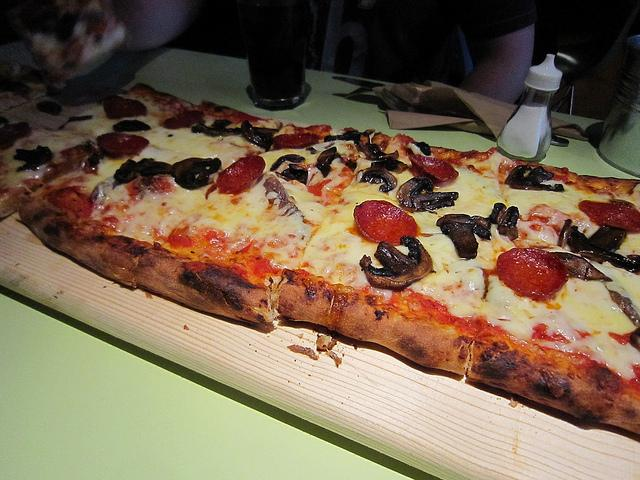What ingredient used as a veg toppings of the pizza? mushroom 